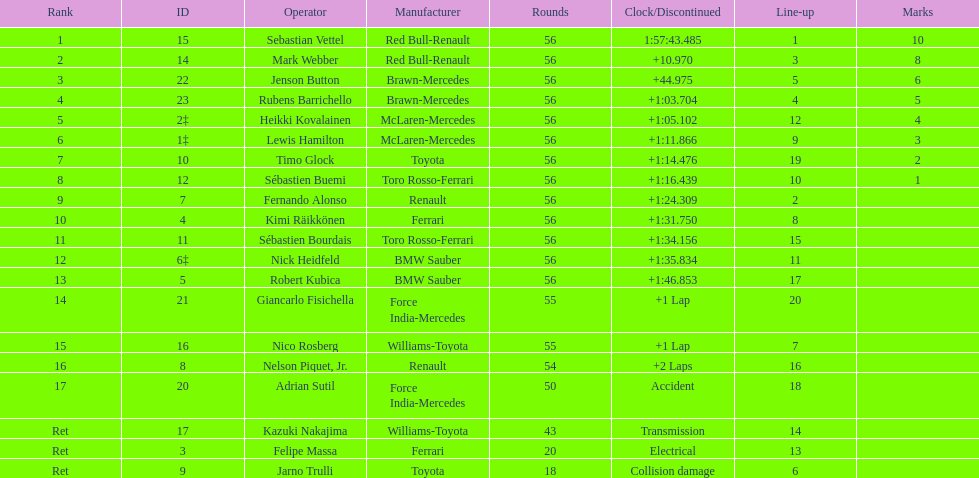Who was at the bottom of the driver list? Jarno Trulli. 